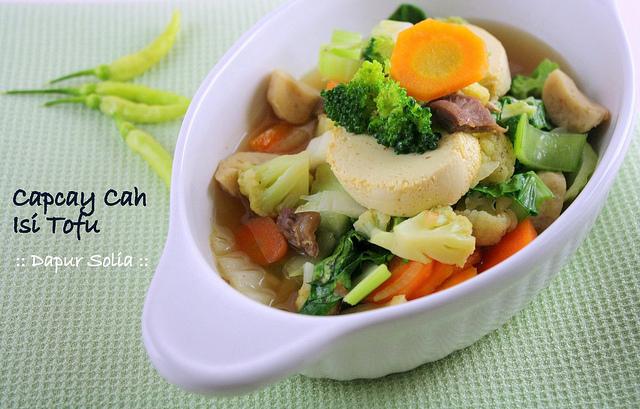What vegetables are lying on the table?
Be succinct. Peppers. Would you consider this to be a healthy meal?
Short answer required. Yes. Is this item likely to be high in sodium?
Answer briefly. No. Is there meat in this dish?
Answer briefly. No. 